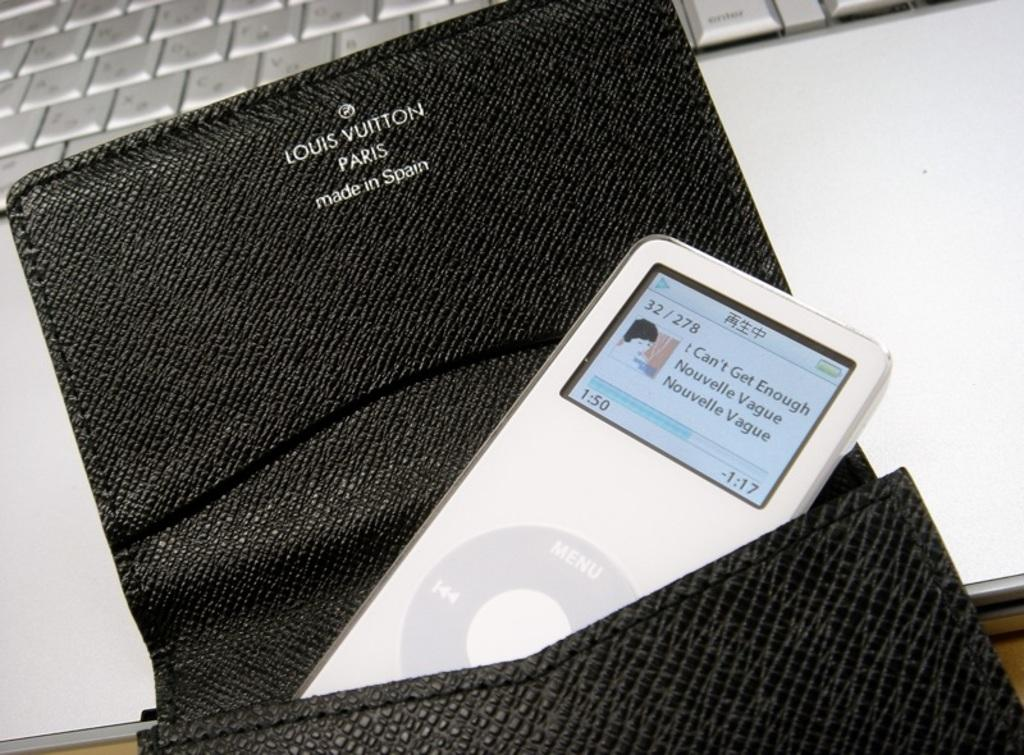What material is located in the center of the image? There is leather in the center of the image. What electronic device is placed on the leather? A cell phone is present on the leather. What other electronic device can be seen in the image? There is a laptop at the top side of the image. What type of fowl is sitting on the scarecrow in the image? There is no fowl or scarecrow present in the image; it only features leather, a cell phone, and a laptop. What type of insurance policy is being advertised on the laptop in the image? There is no information about insurance in the image; it only shows a laptop and a cell phone on leather. 